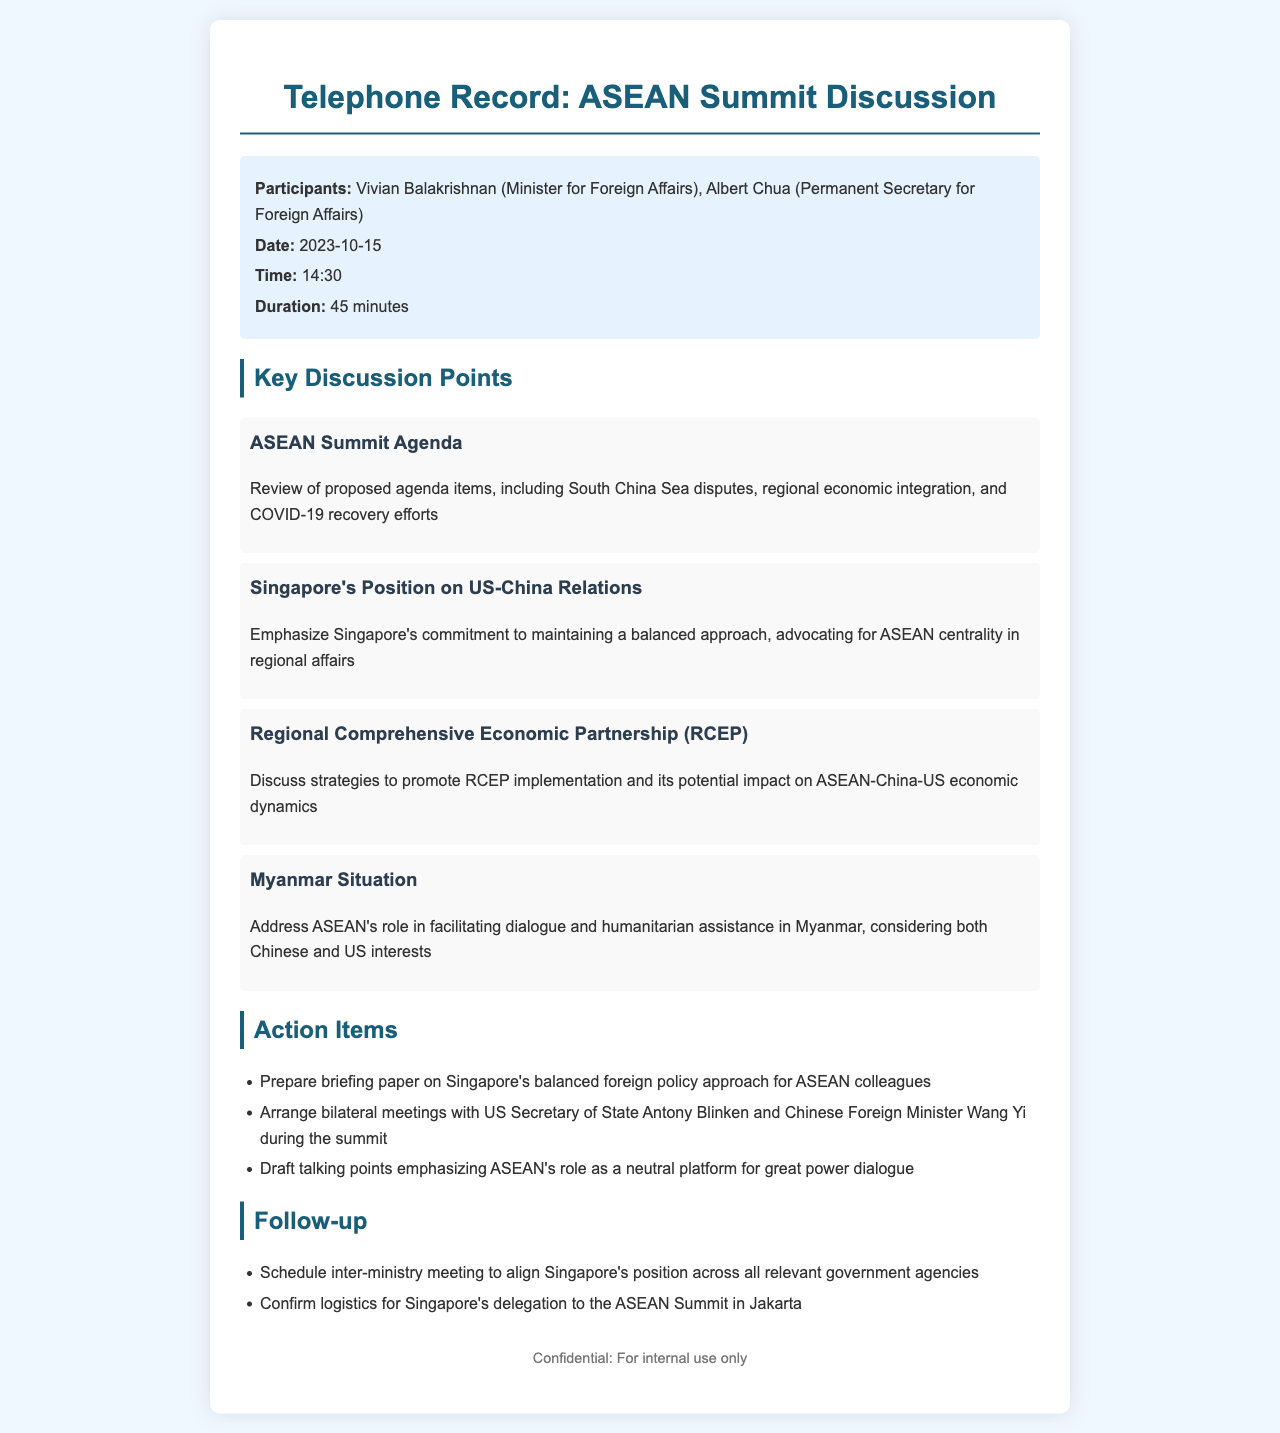what is the date of the call? The date of the call is specified in the document as 2023-10-15.
Answer: 2023-10-15 who participated in the discussion? The participants listed in the document are Vivian Balakrishnan and Albert Chua.
Answer: Vivian Balakrishnan, Albert Chua what was the duration of the call? The duration is stated in the document as 45 minutes.
Answer: 45 minutes what is Singapore's position on US-China relations? The position mentioned is Singapore's commitment to maintaining a balanced approach.
Answer: Balanced approach what action item involves meetings during the summit? The action item related to meetings is to arrange bilateral meetings with US Secretary of State Antony Blinken and Chinese Foreign Minister Wang Yi.
Answer: Arrange bilateral meetings what was discussed regarding the Myanmar situation? The discussion addressed ASEAN's role in facilitating dialogue and humanitarian assistance in Myanmar.
Answer: Facilitating dialogue and humanitarian assistance how many key discussion points are listed in the document? The document lists four key discussion points under the section title.
Answer: Four what is the logistics confirmation related to? The logistics confirmation is regarding Singapore's delegation to the ASEAN Summit in Jakarta.
Answer: ASEAN Summit in Jakarta what is the purpose of the preparation of a briefing paper? The purpose of the briefing paper is to inform ASEAN colleagues about Singapore's balanced foreign policy approach.
Answer: Inform ASEAN colleagues 